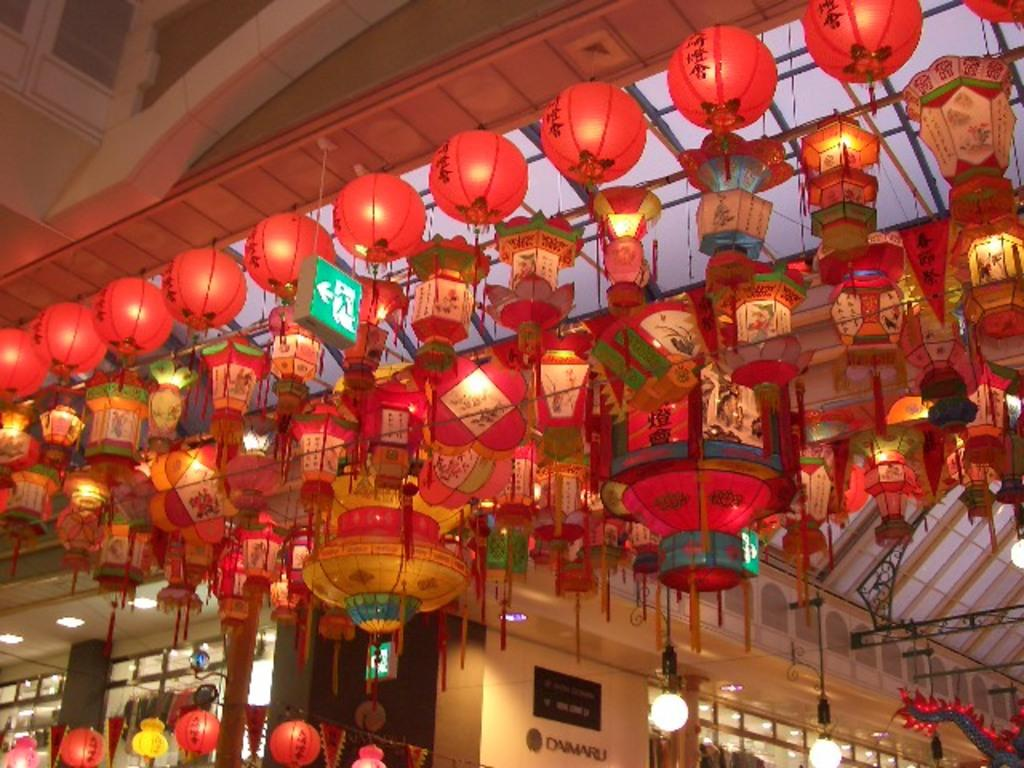What type of decorations are present in the image? There are paper lanterns in the image. How are the lanterns positioned in the image? The lanterns are hanging from the roof. What can be seen illuminating the area in the image? There are lights visible in the image. What type of establishment is depicted in the image? There is a store in the image. What is hanging from the roof along with the lanterns? There is a sign board hanging from the roof in the image. What type of yam is being sold in the store in the image? There is no yam visible in the image, nor is there any indication that the store is selling yams. 